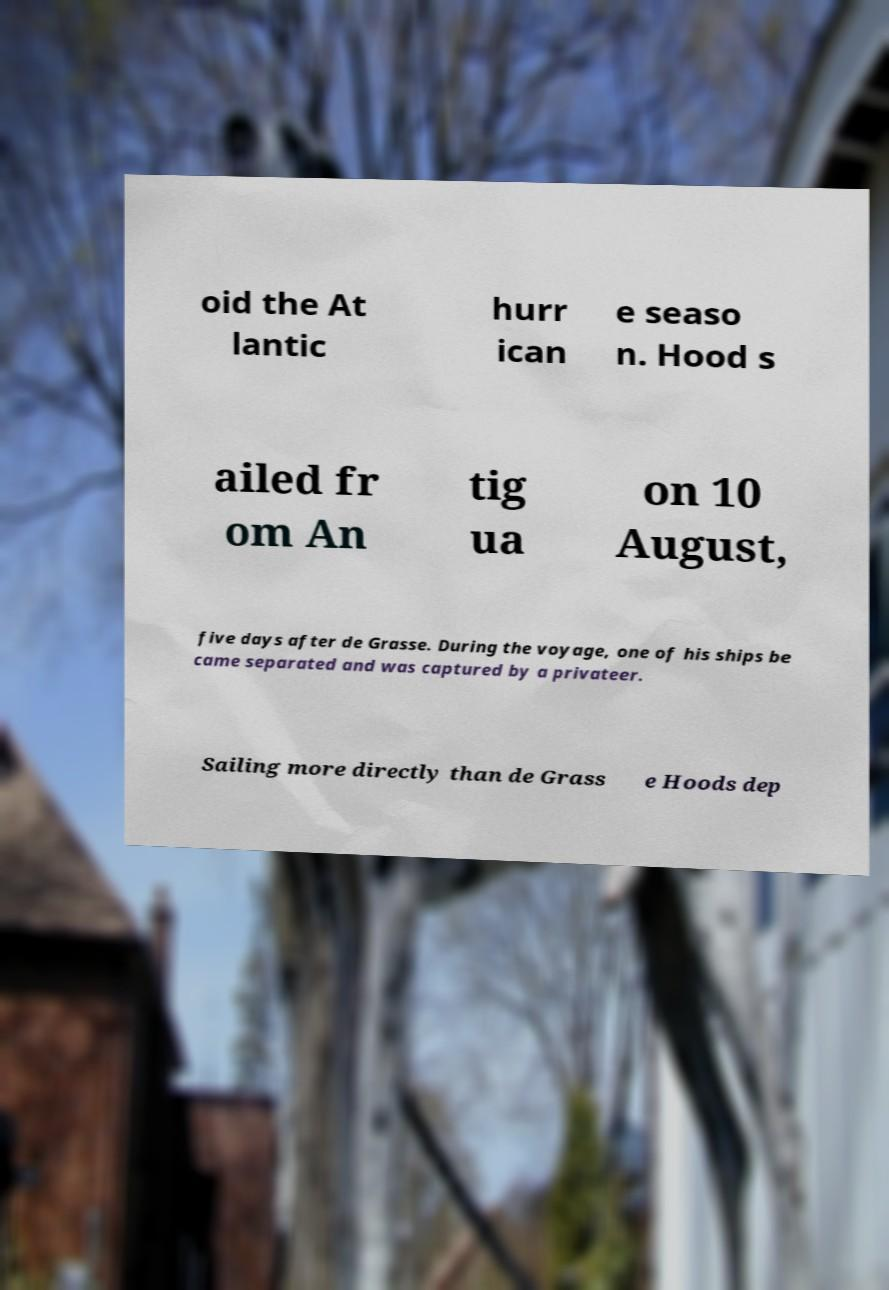I need the written content from this picture converted into text. Can you do that? oid the At lantic hurr ican e seaso n. Hood s ailed fr om An tig ua on 10 August, five days after de Grasse. During the voyage, one of his ships be came separated and was captured by a privateer. Sailing more directly than de Grass e Hoods dep 